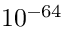Convert formula to latex. <formula><loc_0><loc_0><loc_500><loc_500>1 0 ^ { - 6 4 }</formula> 